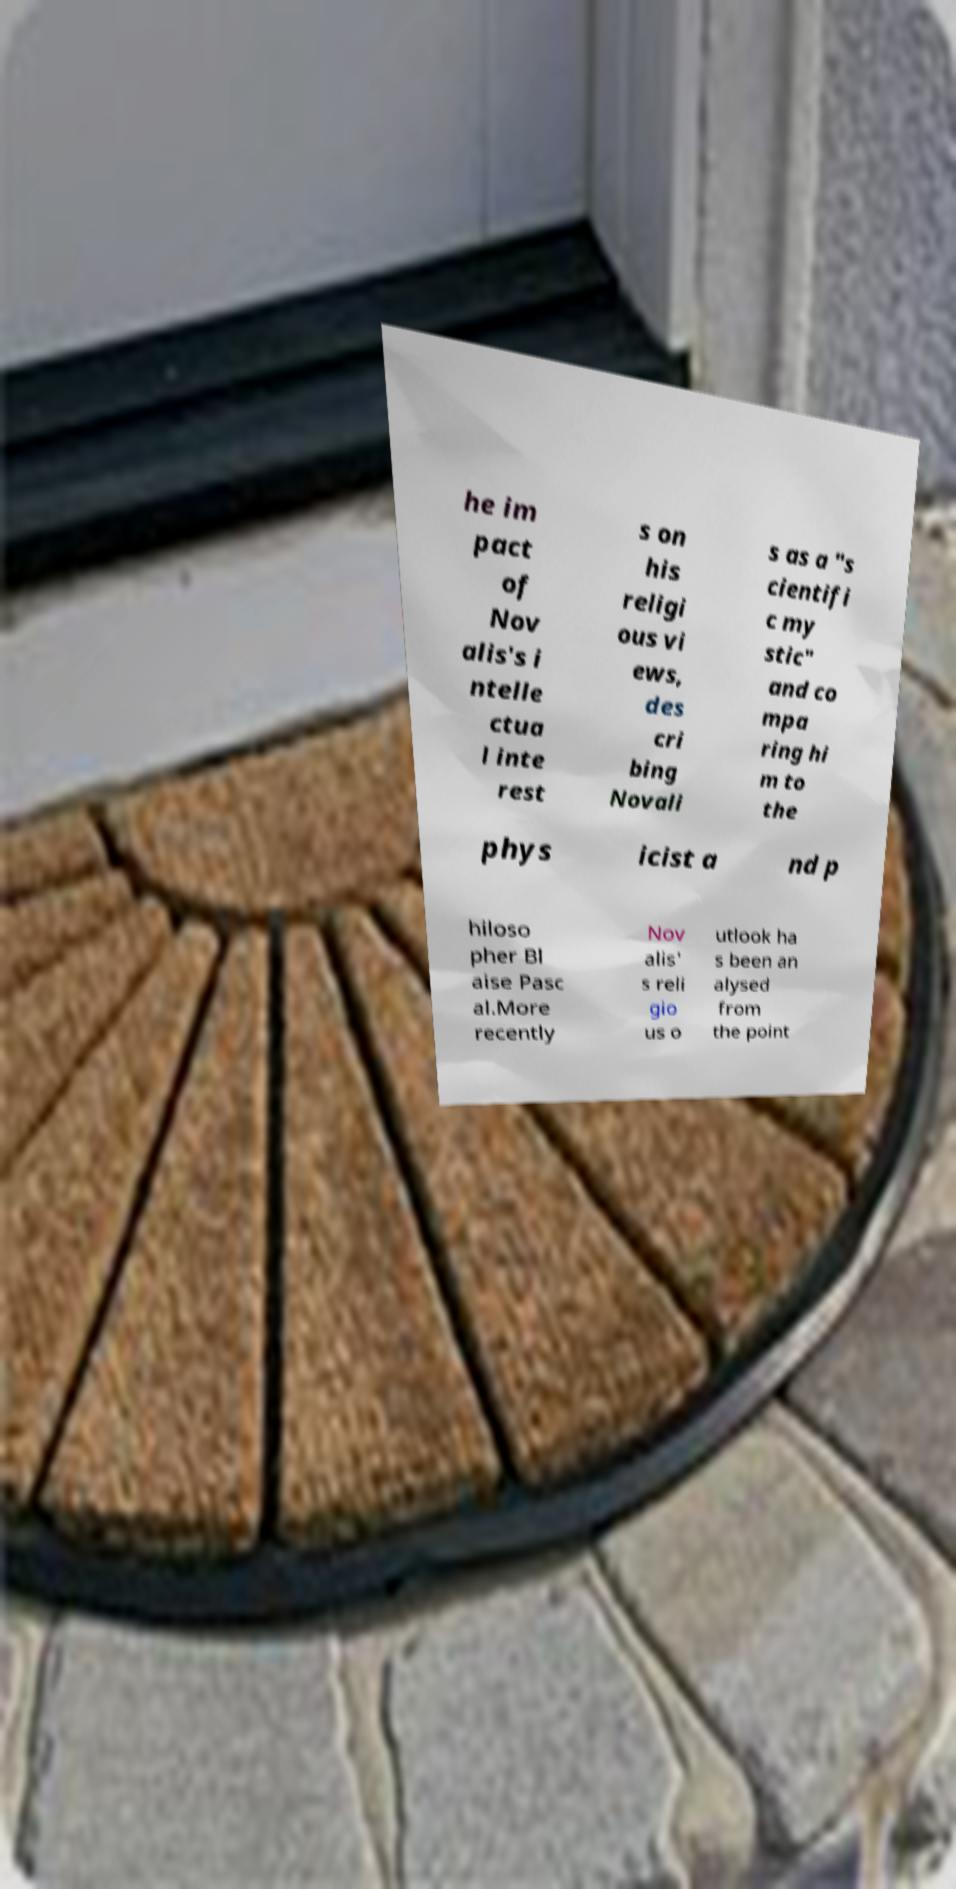Can you accurately transcribe the text from the provided image for me? he im pact of Nov alis's i ntelle ctua l inte rest s on his religi ous vi ews, des cri bing Novali s as a "s cientifi c my stic" and co mpa ring hi m to the phys icist a nd p hiloso pher Bl aise Pasc al.More recently Nov alis' s reli gio us o utlook ha s been an alysed from the point 